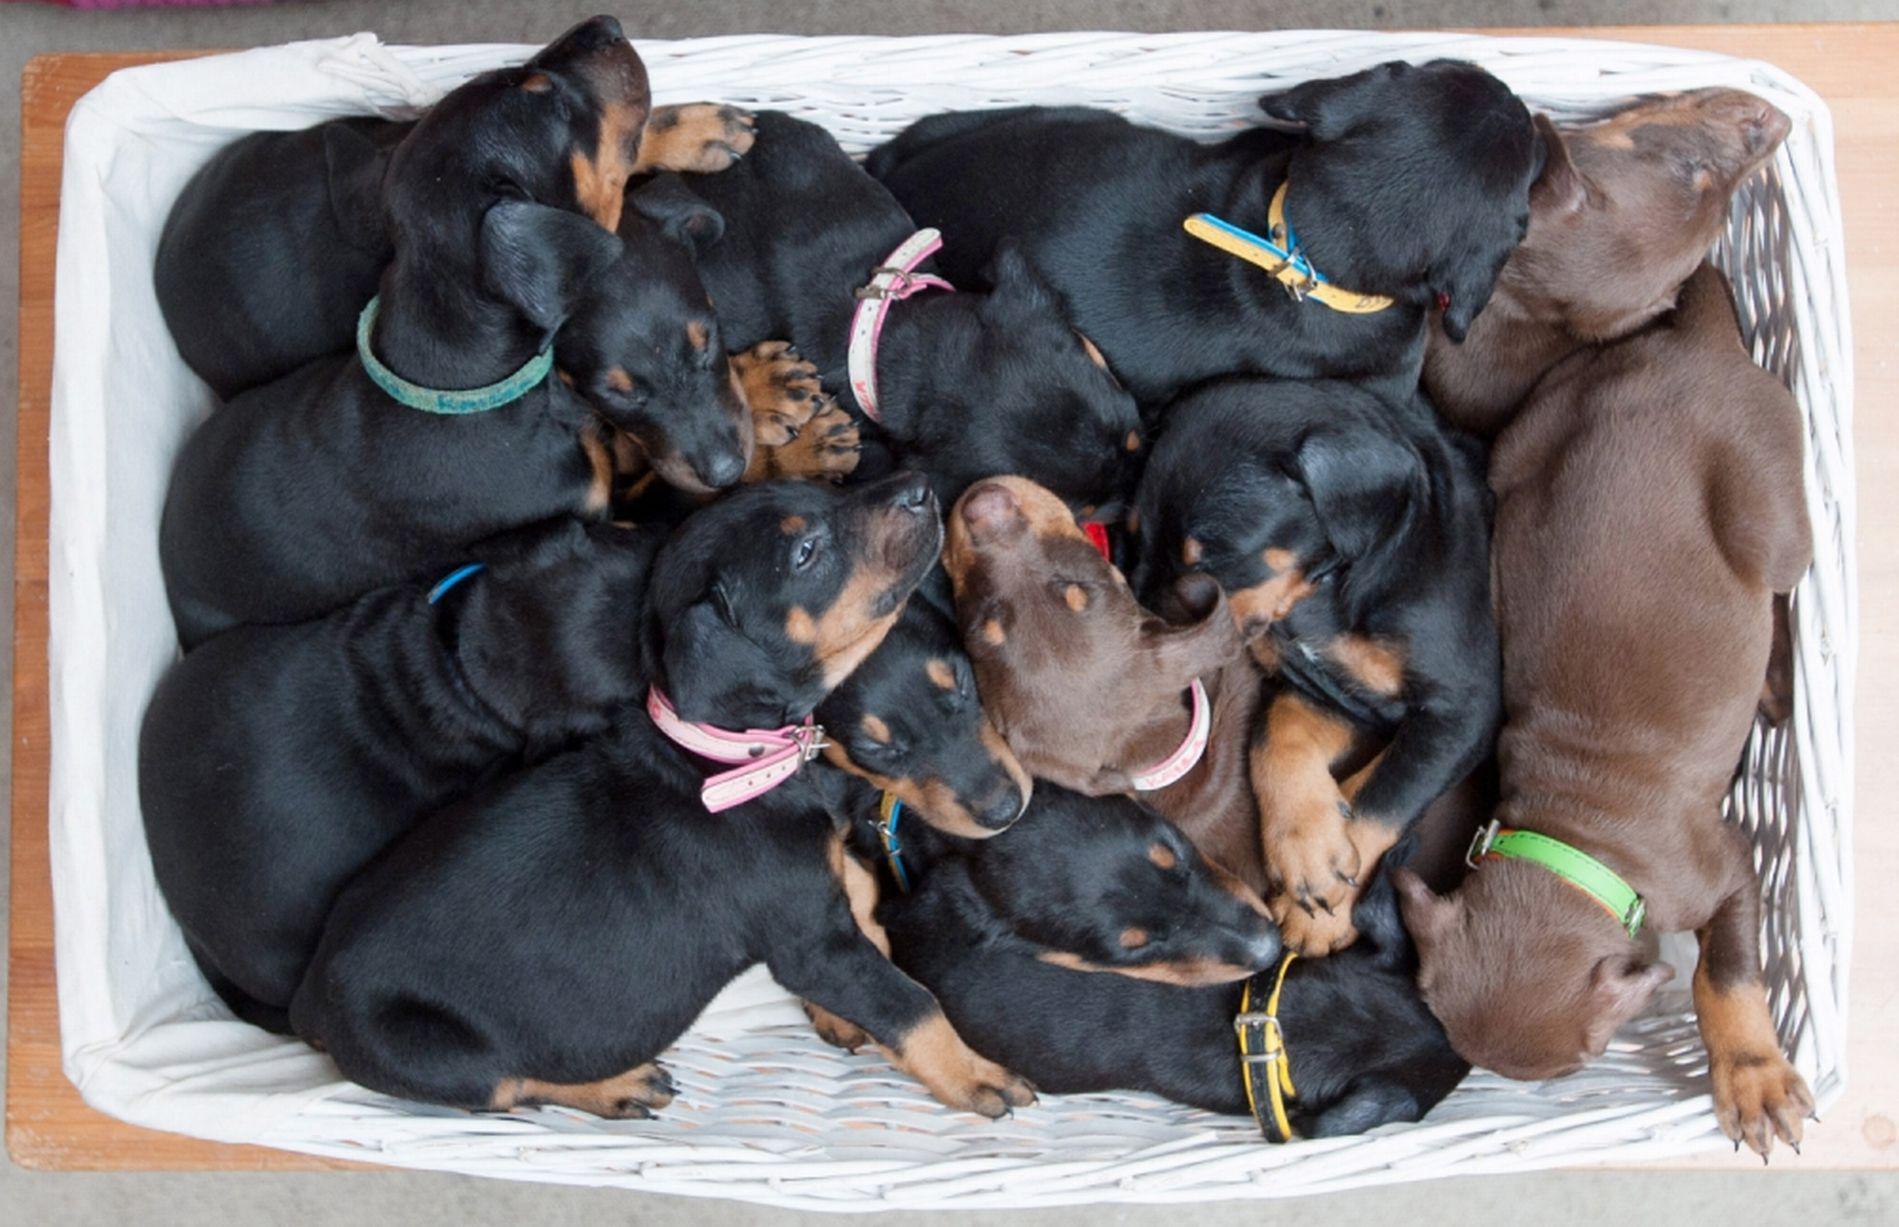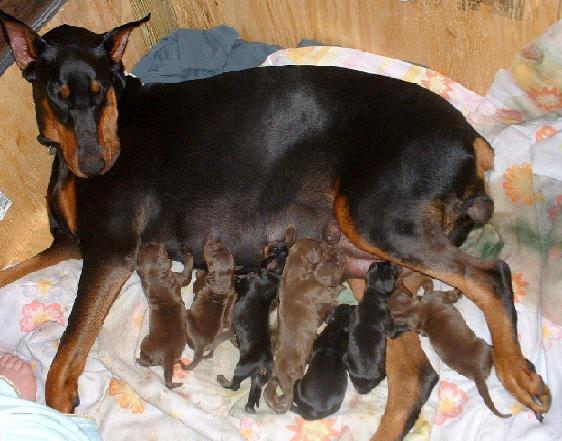The first image is the image on the left, the second image is the image on the right. Evaluate the accuracy of this statement regarding the images: "Dogs are eating out of a bowl.". Is it true? Answer yes or no. No. The first image is the image on the left, the second image is the image on the right. Given the left and right images, does the statement "Multiple puppies are standing around at least part of a round silver bowl shape in at least one image." hold true? Answer yes or no. No. 